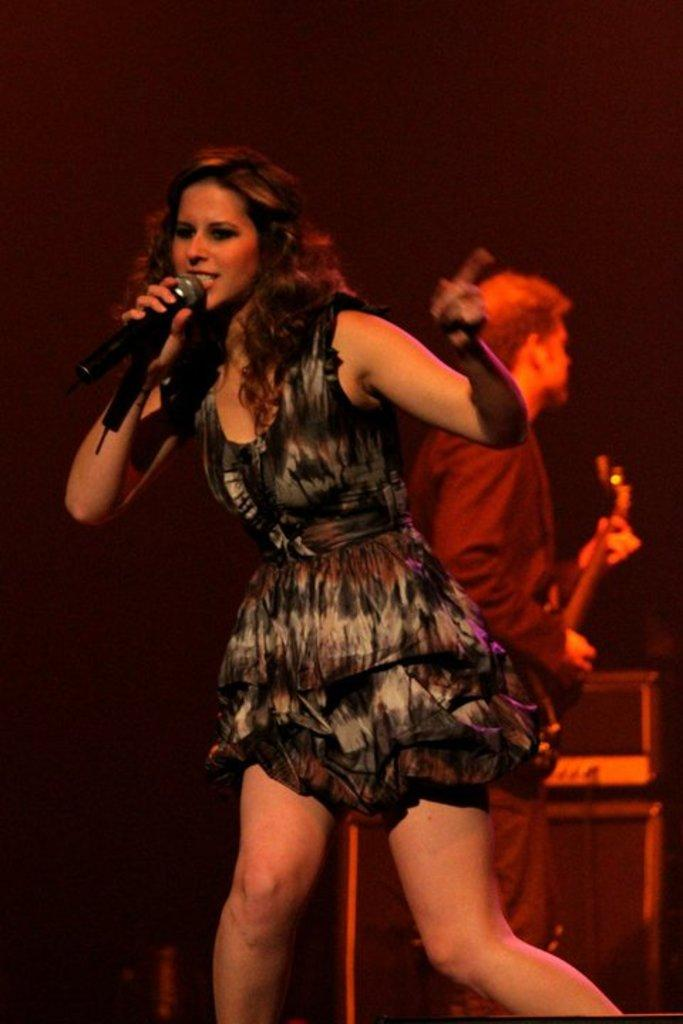Who is the main subject in the image? There is a woman in the center of the image. What is the woman holding in the image? The woman is holding a microphone. Can you describe the man in the background of the image? There is a man in the background of the image, and he is holding a guitar. What type of legal process is the woman attempting to resolve in the image? There is no indication of a legal process in the image; the woman is holding a microphone, and the man is holding a guitar, suggesting a musical context. 